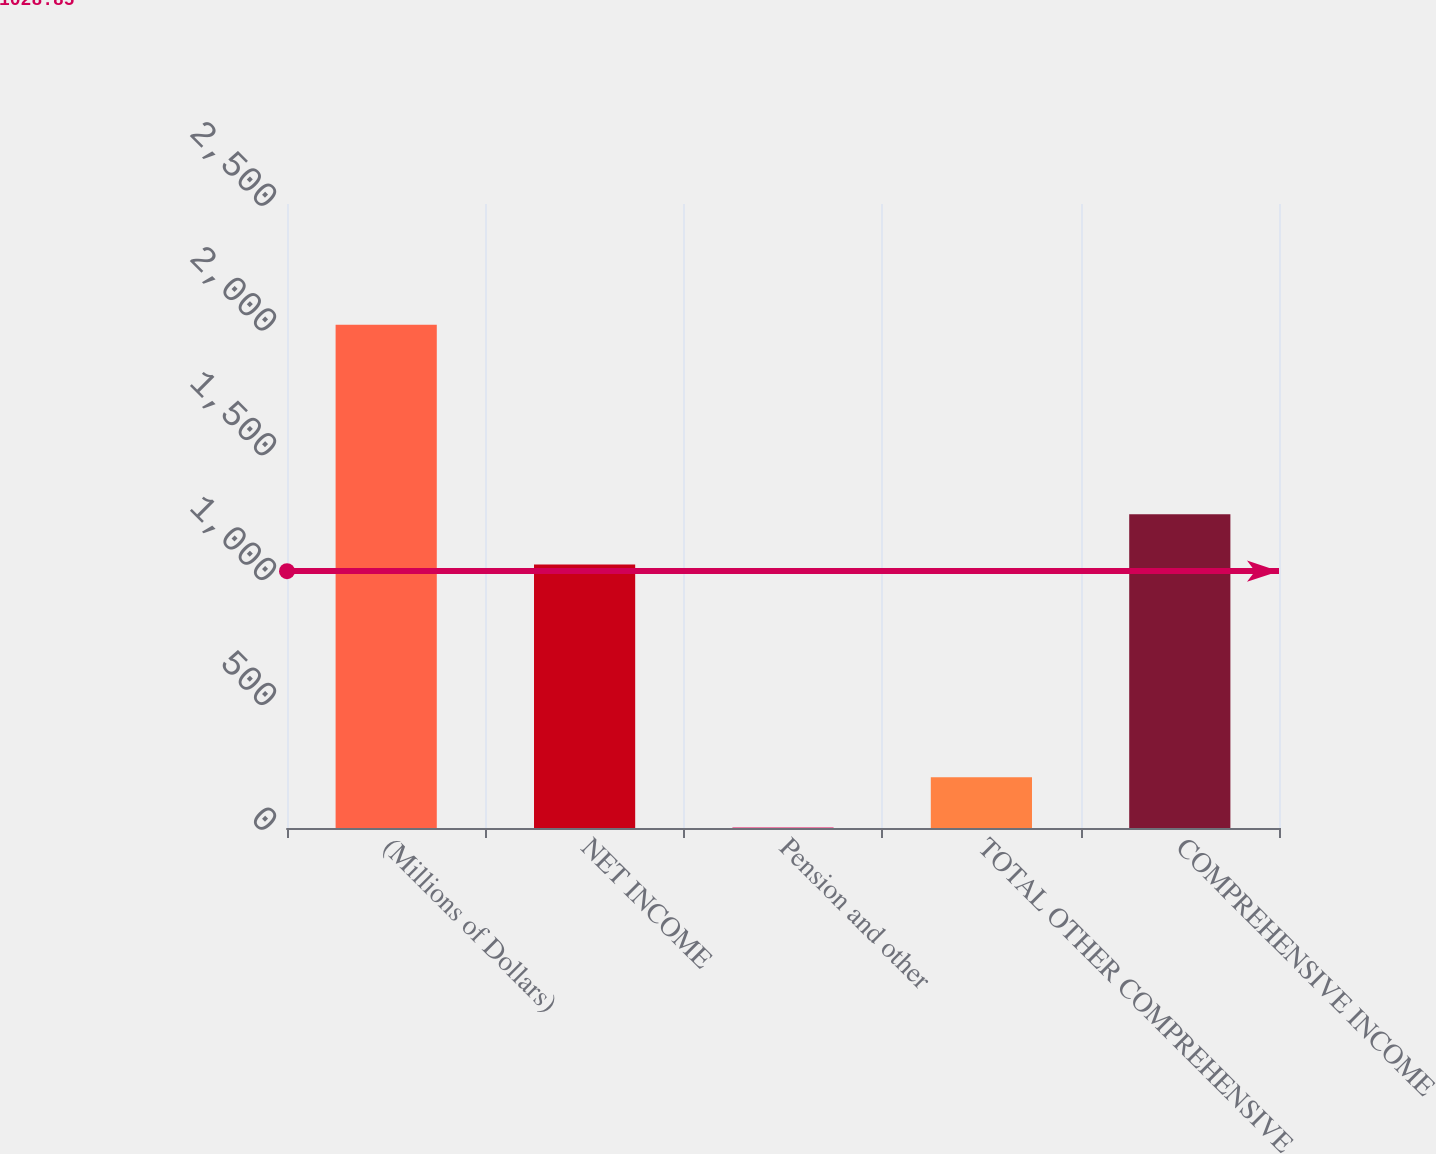Convert chart. <chart><loc_0><loc_0><loc_500><loc_500><bar_chart><fcel>(Millions of Dollars)<fcel>NET INCOME<fcel>Pension and other<fcel>TOTAL OTHER COMPREHENSIVE<fcel>COMPREHENSIVE INCOME<nl><fcel>2016<fcel>1056<fcel>2<fcel>203.4<fcel>1257.4<nl></chart> 